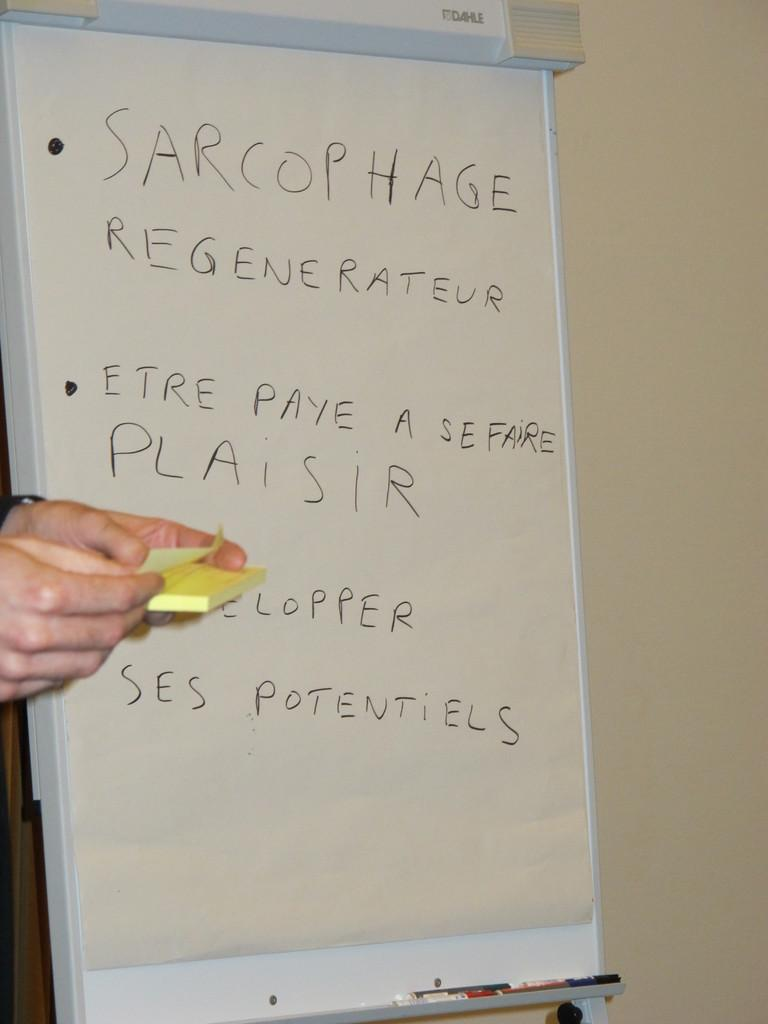<image>
Present a compact description of the photo's key features. A white board with written words including SARCOPHAGE REGENERATEUR. 